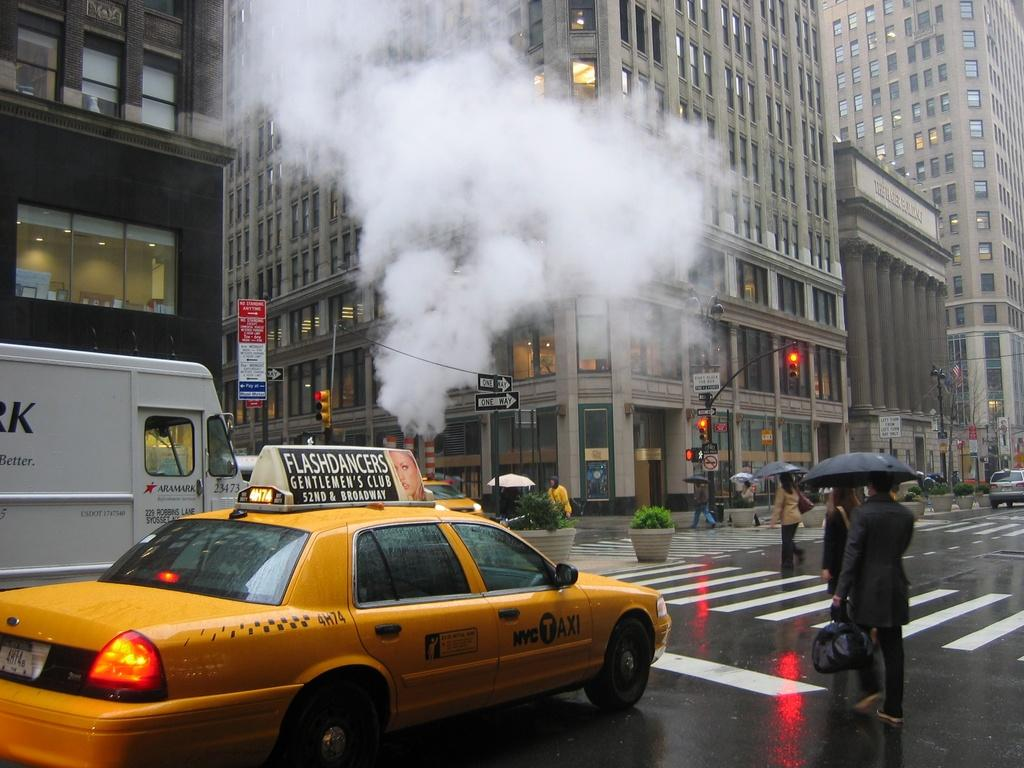<image>
Provide a brief description of the given image. A taxi waits on pedestrians on a rainy day. 